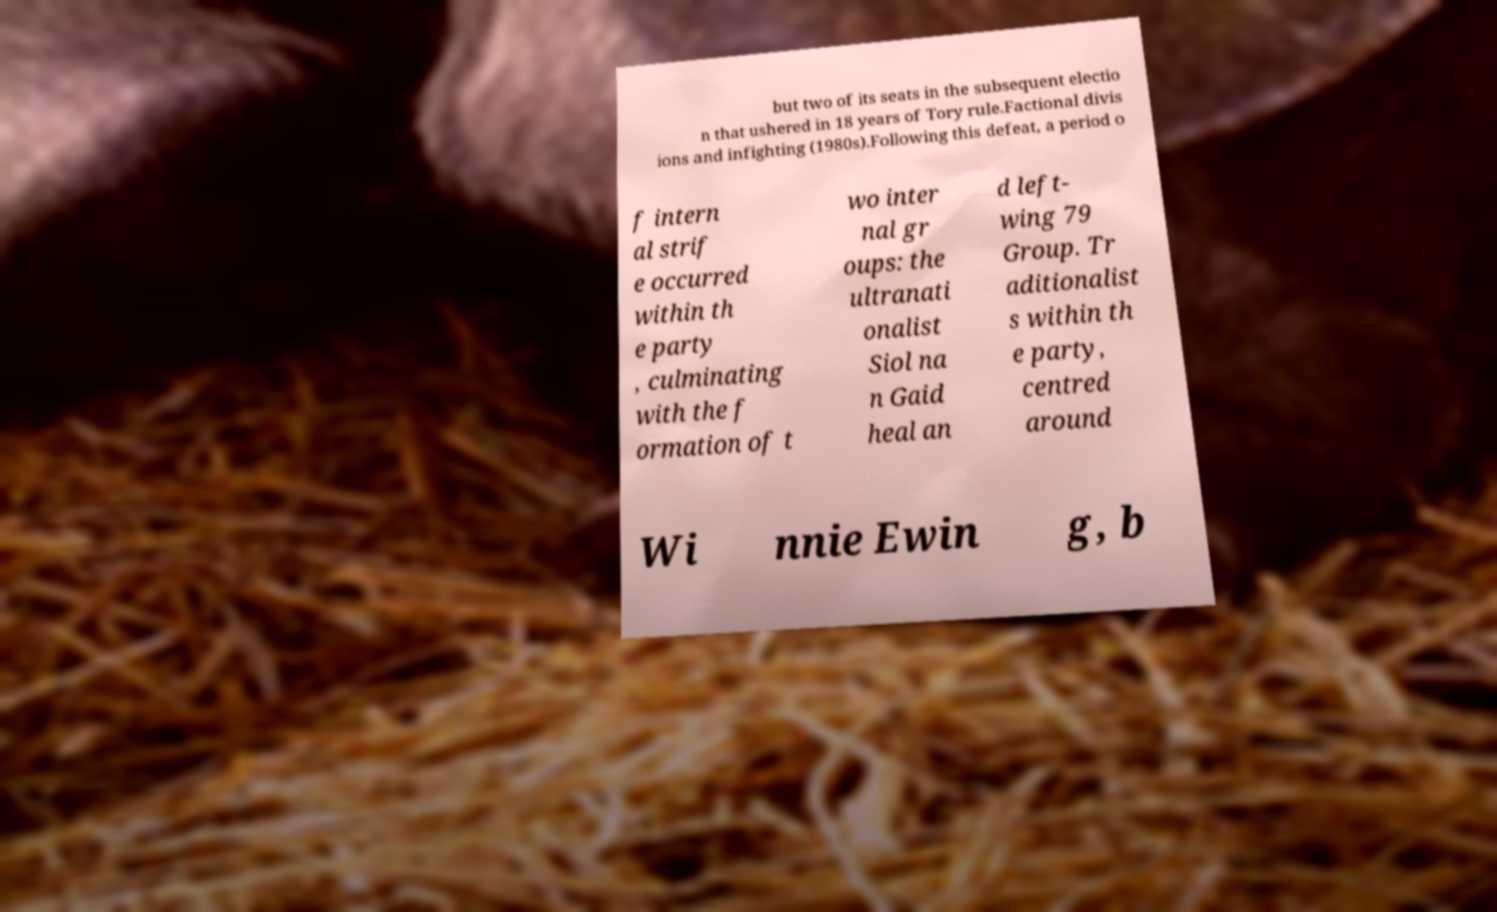I need the written content from this picture converted into text. Can you do that? but two of its seats in the subsequent electio n that ushered in 18 years of Tory rule.Factional divis ions and infighting (1980s).Following this defeat, a period o f intern al strif e occurred within th e party , culminating with the f ormation of t wo inter nal gr oups: the ultranati onalist Siol na n Gaid heal an d left- wing 79 Group. Tr aditionalist s within th e party, centred around Wi nnie Ewin g, b 